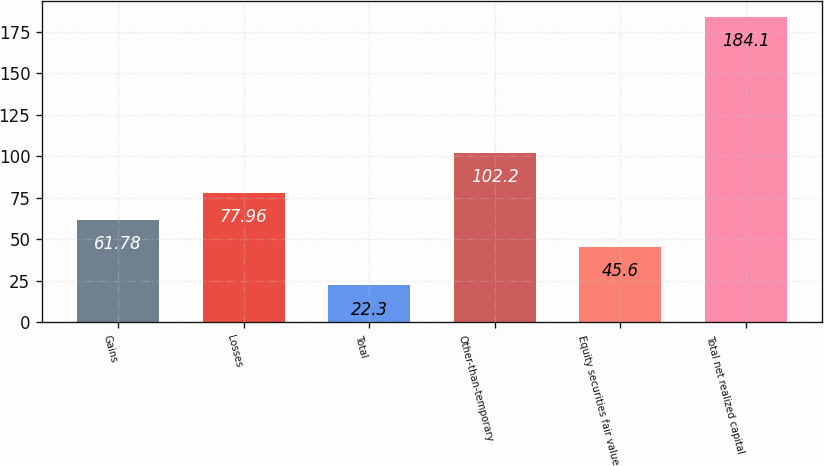Convert chart. <chart><loc_0><loc_0><loc_500><loc_500><bar_chart><fcel>Gains<fcel>Losses<fcel>Total<fcel>Other-than-temporary<fcel>Equity securities fair value<fcel>Total net realized capital<nl><fcel>61.78<fcel>77.96<fcel>22.3<fcel>102.2<fcel>45.6<fcel>184.1<nl></chart> 